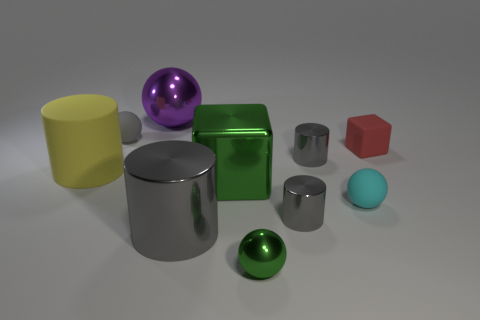Are the cyan ball and the big gray cylinder made of the same material?
Provide a short and direct response. No. What is the material of the gray object that is left of the metal block and behind the yellow matte thing?
Provide a succinct answer. Rubber. What material is the cube that is the same color as the tiny shiny sphere?
Offer a very short reply. Metal. There is a matte ball that is behind the block that is right of the matte sphere on the right side of the big purple ball; what is its size?
Keep it short and to the point. Small. Is the shape of the cyan rubber object the same as the big metal object behind the large matte cylinder?
Your answer should be compact. Yes. Is there a large block of the same color as the small metallic ball?
Ensure brevity in your answer.  Yes. What number of cylinders are either big brown things or large purple objects?
Provide a succinct answer. 0. Is there another small rubber object that has the same shape as the gray matte object?
Your answer should be very brief. Yes. What number of other objects are the same color as the big metallic cube?
Provide a succinct answer. 1. Are there fewer matte spheres that are on the right side of the tiny green metallic ball than big green blocks?
Your answer should be very brief. No. 